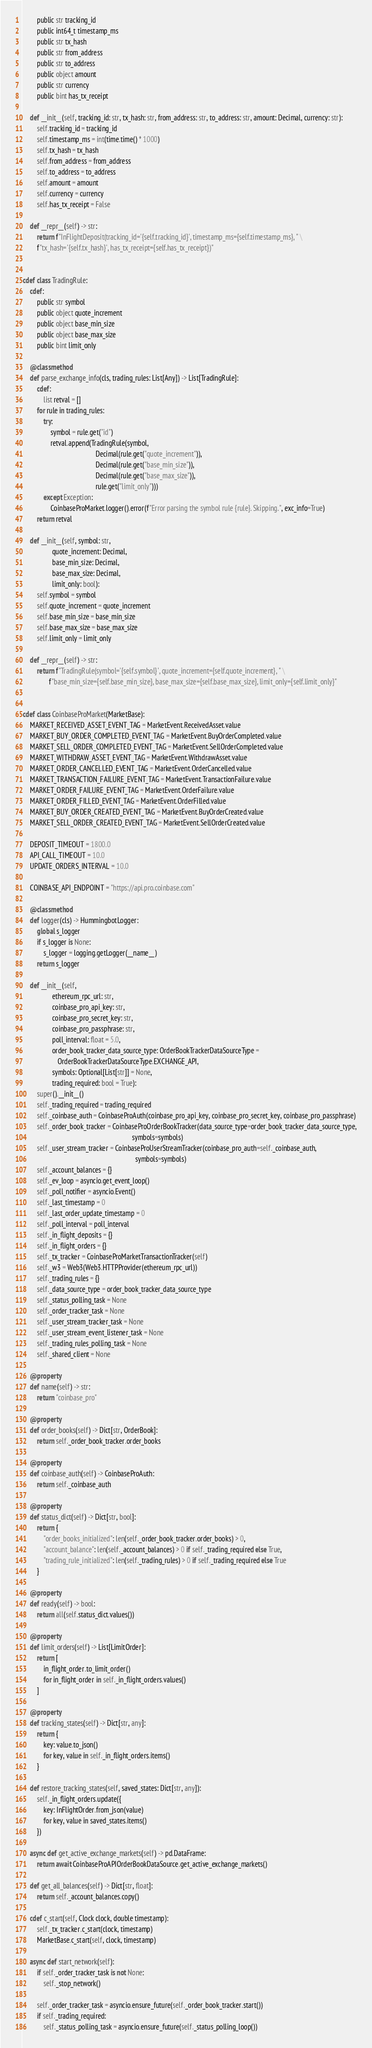<code> <loc_0><loc_0><loc_500><loc_500><_Cython_>        public str tracking_id
        public int64_t timestamp_ms
        public str tx_hash
        public str from_address
        public str to_address
        public object amount
        public str currency
        public bint has_tx_receipt

    def __init__(self, tracking_id: str, tx_hash: str, from_address: str, to_address: str, amount: Decimal, currency: str):
        self.tracking_id = tracking_id
        self.timestamp_ms = int(time.time() * 1000)
        self.tx_hash = tx_hash
        self.from_address = from_address
        self.to_address = to_address
        self.amount = amount
        self.currency = currency
        self.has_tx_receipt = False

    def __repr__(self) -> str:
        return f"InFlightDeposit(tracking_id='{self.tracking_id}', timestamp_ms={self.timestamp_ms}, " \
        f"tx_hash='{self.tx_hash}', has_tx_receipt={self.has_tx_receipt})"


cdef class TradingRule:
    cdef:
        public str symbol
        public object quote_increment
        public object base_min_size
        public object base_max_size
        public bint limit_only

    @classmethod
    def parse_exchange_info(cls, trading_rules: List[Any]) -> List[TradingRule]:
        cdef:
            list retval = []
        for rule in trading_rules:
            try:
                symbol = rule.get("id")
                retval.append(TradingRule(symbol,
                                          Decimal(rule.get("quote_increment")),
                                          Decimal(rule.get("base_min_size")),
                                          Decimal(rule.get("base_max_size")),
                                          rule.get("limit_only")))
            except Exception:
                CoinbaseProMarket.logger().error(f"Error parsing the symbol rule {rule}. Skipping.", exc_info=True)
        return retval

    def __init__(self, symbol: str,
                 quote_increment: Decimal,
                 base_min_size: Decimal,
                 base_max_size: Decimal,
                 limit_only: bool):
        self.symbol = symbol
        self.quote_increment = quote_increment
        self.base_min_size = base_min_size
        self.base_max_size = base_max_size
        self.limit_only = limit_only

    def __repr__(self) -> str:
        return f"TradingRule(symbol='{self.symbol}', quote_increment={self.quote_increment}, " \
               f"base_min_size={self.base_min_size}, base_max_size={self.base_max_size}, limit_only={self.limit_only}"


cdef class CoinbaseProMarket(MarketBase):
    MARKET_RECEIVED_ASSET_EVENT_TAG = MarketEvent.ReceivedAsset.value
    MARKET_BUY_ORDER_COMPLETED_EVENT_TAG = MarketEvent.BuyOrderCompleted.value
    MARKET_SELL_ORDER_COMPLETED_EVENT_TAG = MarketEvent.SellOrderCompleted.value
    MARKET_WITHDRAW_ASSET_EVENT_TAG = MarketEvent.WithdrawAsset.value
    MARKET_ORDER_CANCELLED_EVENT_TAG = MarketEvent.OrderCancelled.value
    MARKET_TRANSACTION_FAILURE_EVENT_TAG = MarketEvent.TransactionFailure.value
    MARKET_ORDER_FAILURE_EVENT_TAG = MarketEvent.OrderFailure.value
    MARKET_ORDER_FILLED_EVENT_TAG = MarketEvent.OrderFilled.value
    MARKET_BUY_ORDER_CREATED_EVENT_TAG = MarketEvent.BuyOrderCreated.value
    MARKET_SELL_ORDER_CREATED_EVENT_TAG = MarketEvent.SellOrderCreated.value

    DEPOSIT_TIMEOUT = 1800.0
    API_CALL_TIMEOUT = 10.0
    UPDATE_ORDERS_INTERVAL = 10.0

    COINBASE_API_ENDPOINT = "https://api.pro.coinbase.com"

    @classmethod
    def logger(cls) -> HummingbotLogger:
        global s_logger
        if s_logger is None:
            s_logger = logging.getLogger(__name__)
        return s_logger

    def __init__(self,
                 ethereum_rpc_url: str,
                 coinbase_pro_api_key: str,
                 coinbase_pro_secret_key: str,
                 coinbase_pro_passphrase: str,
                 poll_interval: float = 5.0,
                 order_book_tracker_data_source_type: OrderBookTrackerDataSourceType =
                    OrderBookTrackerDataSourceType.EXCHANGE_API,
                 symbols: Optional[List[str]] = None,
                 trading_required: bool = True):
        super().__init__()
        self._trading_required = trading_required
        self._coinbase_auth = CoinbaseProAuth(coinbase_pro_api_key, coinbase_pro_secret_key, coinbase_pro_passphrase)
        self._order_book_tracker = CoinbaseProOrderBookTracker(data_source_type=order_book_tracker_data_source_type,
                                                               symbols=symbols)
        self._user_stream_tracker = CoinbaseProUserStreamTracker(coinbase_pro_auth=self._coinbase_auth,
                                                                 symbols=symbols)
        self._account_balances = {}
        self._ev_loop = asyncio.get_event_loop()
        self._poll_notifier = asyncio.Event()
        self._last_timestamp = 0
        self._last_order_update_timestamp = 0
        self._poll_interval = poll_interval
        self._in_flight_deposits = {}
        self._in_flight_orders = {}
        self._tx_tracker = CoinbaseProMarketTransactionTracker(self)
        self._w3 = Web3(Web3.HTTPProvider(ethereum_rpc_url))
        self._trading_rules = {}
        self._data_source_type = order_book_tracker_data_source_type
        self._status_polling_task = None
        self._order_tracker_task = None
        self._user_stream_tracker_task = None
        self._user_stream_event_listener_task = None
        self._trading_rules_polling_task = None
        self._shared_client = None

    @property
    def name(self) -> str:
        return "coinbase_pro"

    @property
    def order_books(self) -> Dict[str, OrderBook]:
        return self._order_book_tracker.order_books

    @property
    def coinbase_auth(self) -> CoinbaseProAuth:
        return self._coinbase_auth

    @property
    def status_dict(self) -> Dict[str, bool]:
        return {
            "order_books_initialized": len(self._order_book_tracker.order_books) > 0,
            "account_balance": len(self._account_balances) > 0 if self._trading_required else True,
            "trading_rule_initialized": len(self._trading_rules) > 0 if self._trading_required else True
        }

    @property
    def ready(self) -> bool:
        return all(self.status_dict.values())

    @property
    def limit_orders(self) -> List[LimitOrder]:
        return [
            in_flight_order.to_limit_order()
            for in_flight_order in self._in_flight_orders.values()
        ]

    @property
    def tracking_states(self) -> Dict[str, any]:
        return {
            key: value.to_json()
            for key, value in self._in_flight_orders.items()
        }

    def restore_tracking_states(self, saved_states: Dict[str, any]):
        self._in_flight_orders.update({
            key: InFlightOrder.from_json(value)
            for key, value in saved_states.items()
        })

    async def get_active_exchange_markets(self) -> pd.DataFrame:
        return await CoinbaseProAPIOrderBookDataSource.get_active_exchange_markets()

    def get_all_balances(self) -> Dict[str, float]:
        return self._account_balances.copy()

    cdef c_start(self, Clock clock, double timestamp):
        self._tx_tracker.c_start(clock, timestamp)
        MarketBase.c_start(self, clock, timestamp)

    async def start_network(self):
        if self._order_tracker_task is not None:
            self._stop_network()

        self._order_tracker_task = asyncio.ensure_future(self._order_book_tracker.start())
        if self._trading_required:
            self._status_polling_task = asyncio.ensure_future(self._status_polling_loop())</code> 